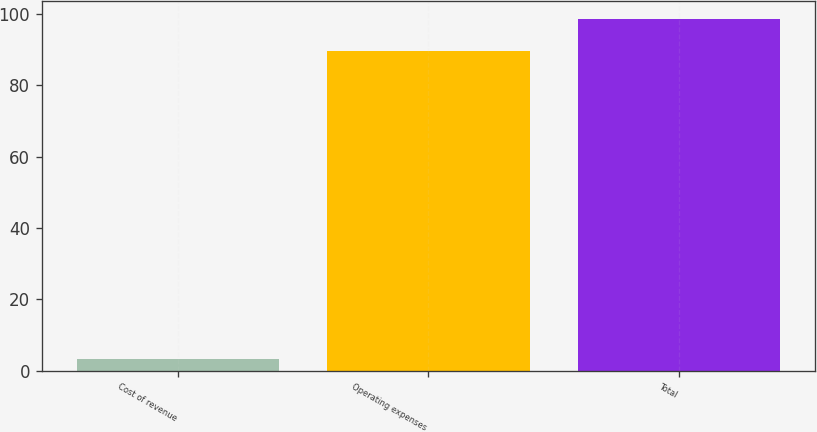Convert chart to OTSL. <chart><loc_0><loc_0><loc_500><loc_500><bar_chart><fcel>Cost of revenue<fcel>Operating expenses<fcel>Total<nl><fcel>3.3<fcel>89.7<fcel>98.67<nl></chart> 